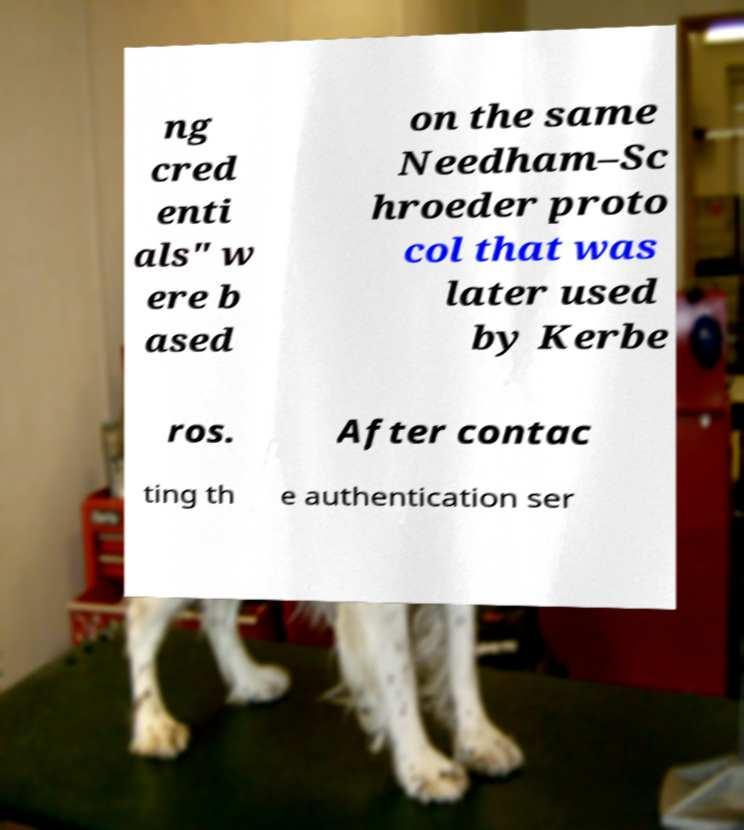Please read and relay the text visible in this image. What does it say? ng cred enti als" w ere b ased on the same Needham–Sc hroeder proto col that was later used by Kerbe ros. After contac ting th e authentication ser 